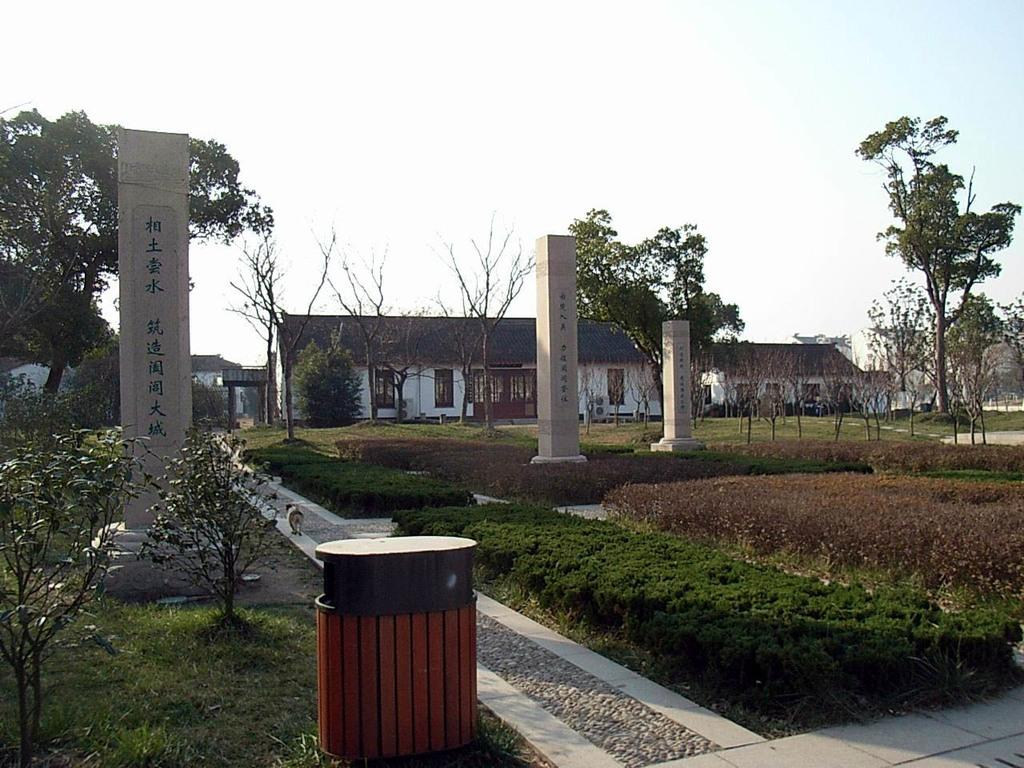What type of vegetation is present in the image? There is grass in the image. What architectural features can be seen in the image? There are pillars in the image. What other natural elements are visible in the image? There are trees in the image. What type of structures are present in the image? There are houses in the image. What animal can be seen on the pavement in the image? There is a dog on the pavement in the image. How many heads of lettuce are resting on the dog in the image? There are no heads of lettuce present in the image, and the dog is not resting on any object. 